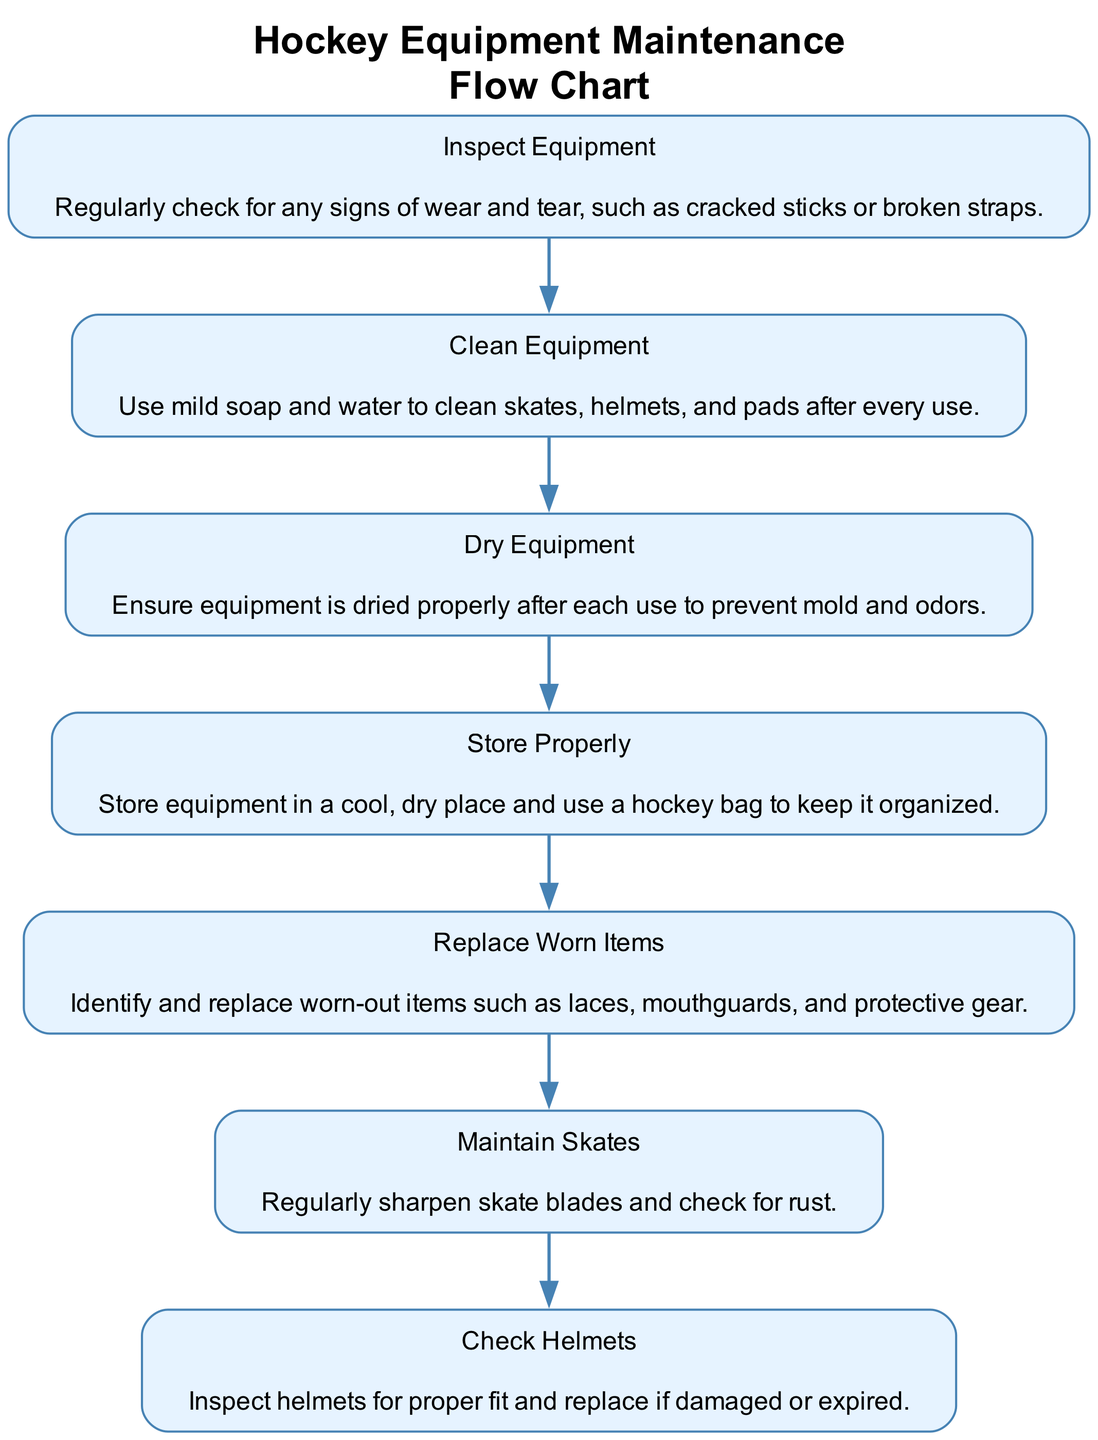What is the first step in maintaining hockey equipment? The first step listed in the flow chart is "Inspect Equipment," which means regularly checking for signs of wear and tear.
Answer: Inspect Equipment How many steps are in the maintenance process? By counting the number of nodes in the diagram, there are a total of 7 steps listed for maintaining hockey equipment.
Answer: 7 What step comes after "Dry Equipment"? Following the "Dry Equipment" step, the next step in the sequence is "Store Properly," which involves keeping equipment organized and in a cool, dry place.
Answer: Store Properly Which step includes checking for rust? The step that includes checking for rust is "Maintain Skates," which emphasizes the importance of regular skate blade maintenance.
Answer: Maintain Skates What items should be replaced according to the flow chart? The flow chart mentions replacing worn items such as laces, mouthguards, and protective gear as part of the "Replace Worn Items" step.
Answer: Laces, mouthguards, protective gear What are the two actions involved in caring for skates? The two actions are "Regularly sharpen skate blades" and "check for rust," as outlined in the "Maintain Skates" step of the flow chart.
Answer: Sharpen and check for rust Which step occurs directly before "Check Helmets"? The step that occurs directly before "Check Helmets" is "Maintain Skates." It signifies that skates are maintained prior to helmet checks.
Answer: Maintain Skates What is the primary goal of "Clean Equipment"? The primary goal of "Clean Equipment" is to use mild soap and water to clean skates, helmets, and pads after every use.
Answer: Use mild soap and water Which step emphasizes the importance of mold prevention? The step that emphasizes the importance of mold prevention is "Dry Equipment," as ensuring proper drying stops mold and odors from developing.
Answer: Dry Equipment 